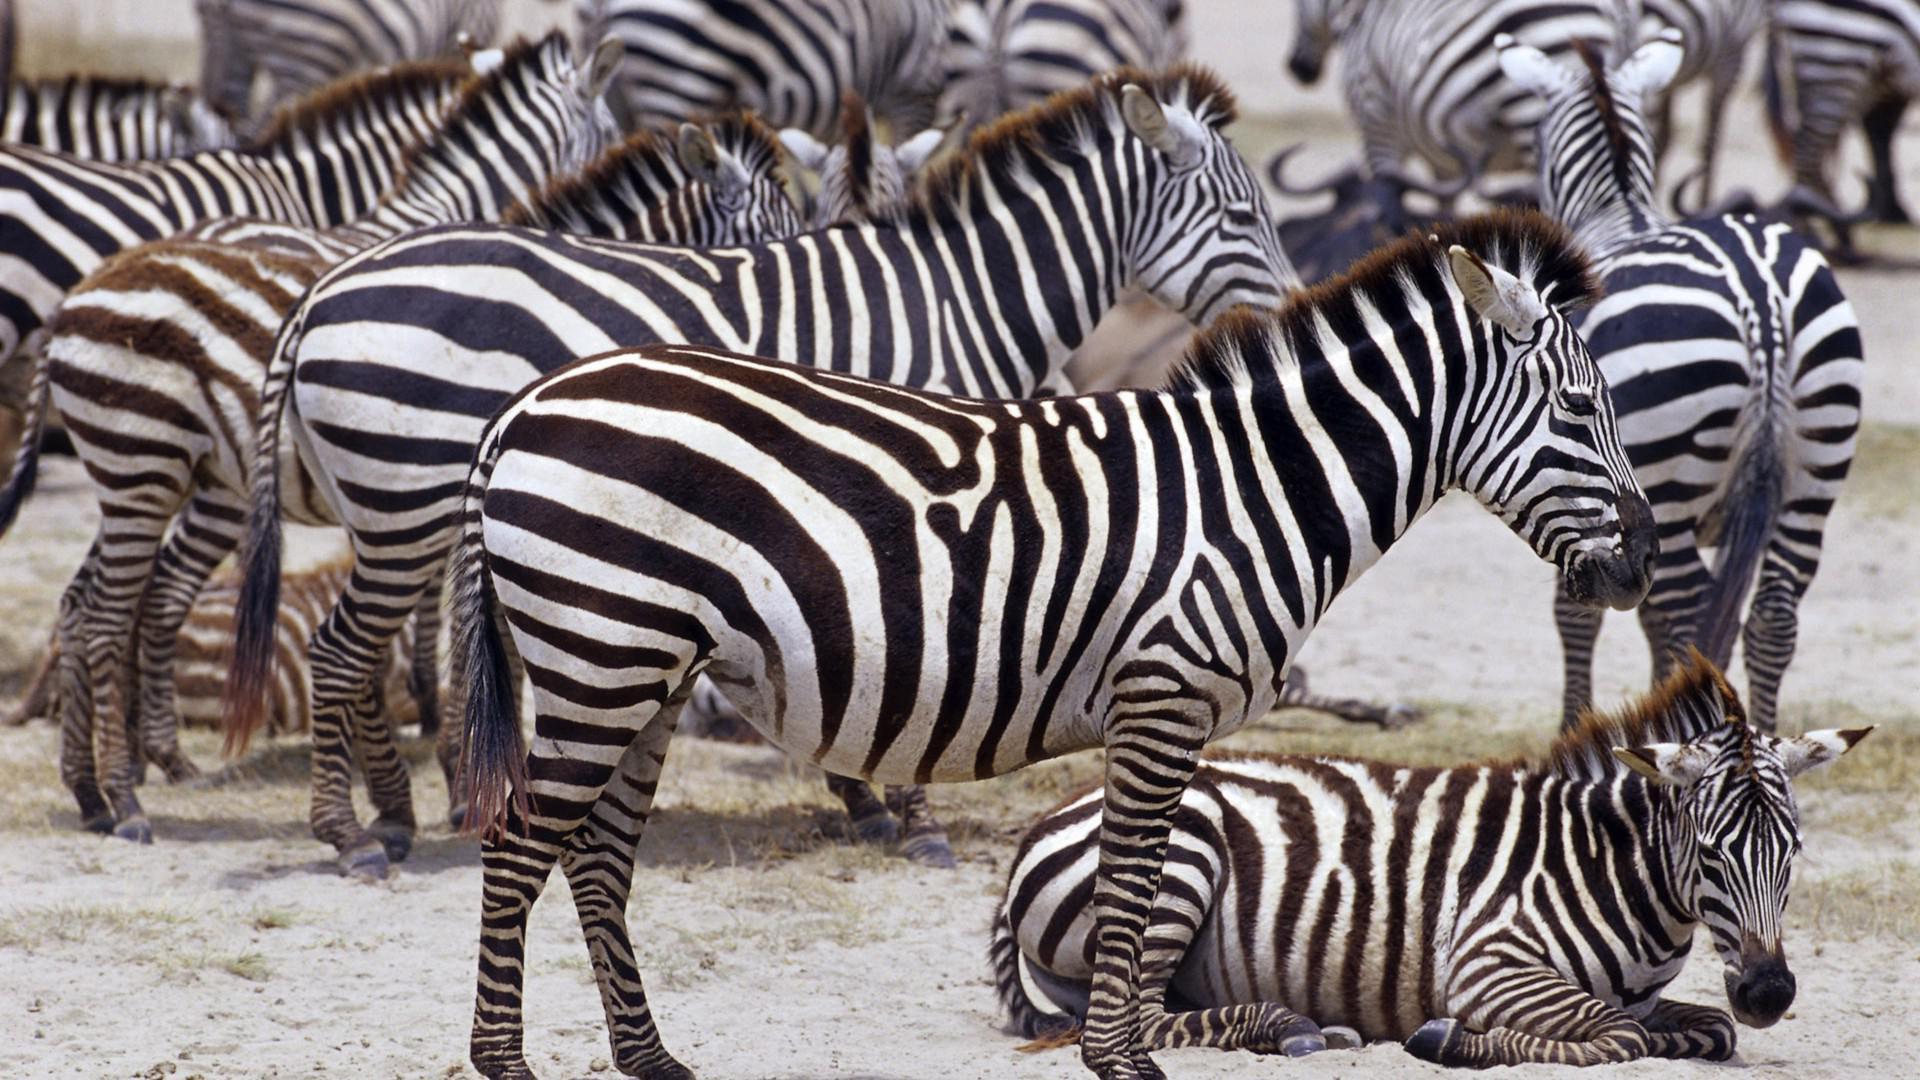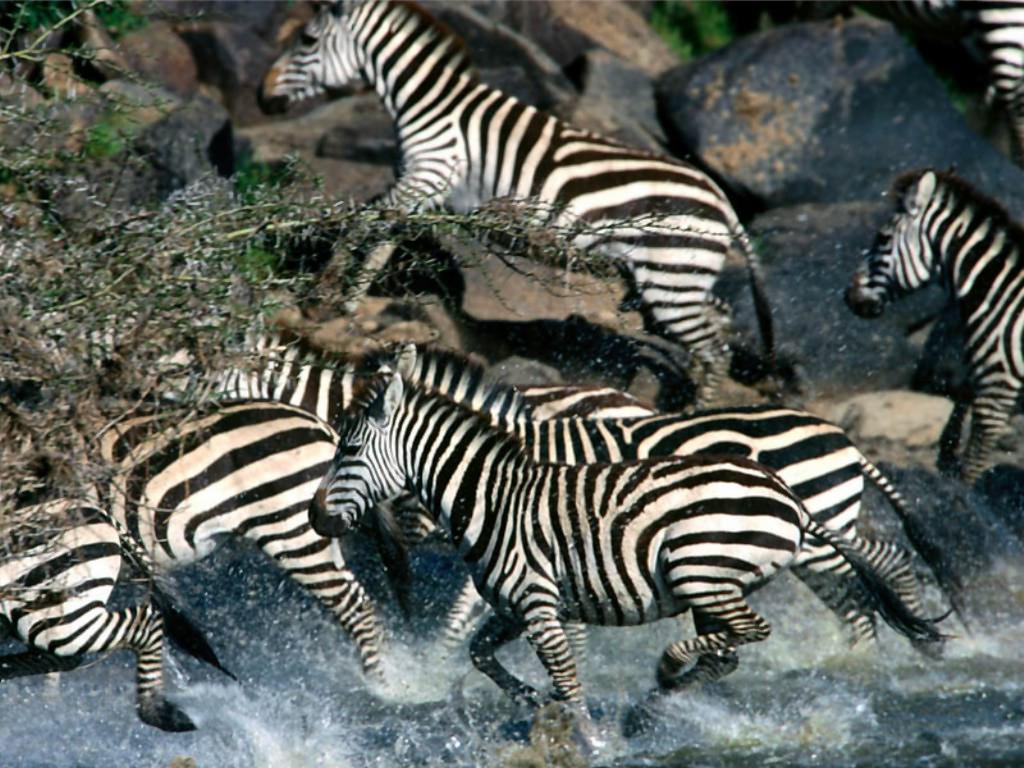The first image is the image on the left, the second image is the image on the right. Analyze the images presented: Is the assertion "The zebras in one of the images are drinking from a body of water." valid? Answer yes or no. No. The first image is the image on the left, the second image is the image on the right. For the images shown, is this caption "One image shows zebras with necks extending from the right lined up to drink, with heads bent to the water." true? Answer yes or no. No. 